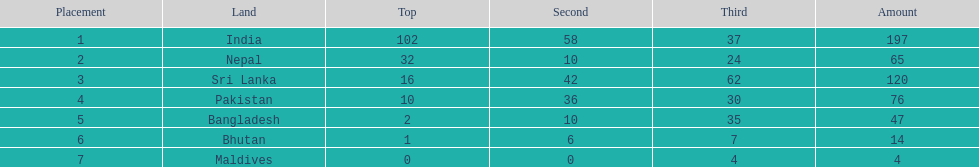Which nation has earned the least amount of gold medals? Maldives. 